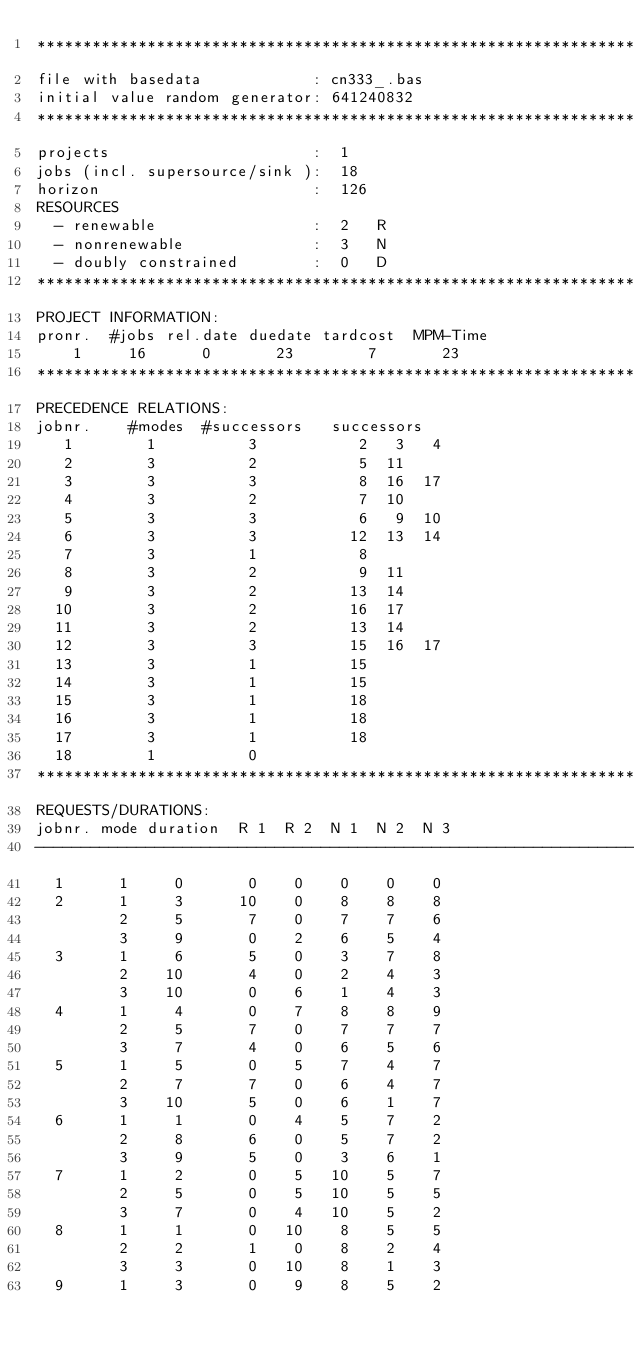<code> <loc_0><loc_0><loc_500><loc_500><_ObjectiveC_>************************************************************************
file with basedata            : cn333_.bas
initial value random generator: 641240832
************************************************************************
projects                      :  1
jobs (incl. supersource/sink ):  18
horizon                       :  126
RESOURCES
  - renewable                 :  2   R
  - nonrenewable              :  3   N
  - doubly constrained        :  0   D
************************************************************************
PROJECT INFORMATION:
pronr.  #jobs rel.date duedate tardcost  MPM-Time
    1     16      0       23        7       23
************************************************************************
PRECEDENCE RELATIONS:
jobnr.    #modes  #successors   successors
   1        1          3           2   3   4
   2        3          2           5  11
   3        3          3           8  16  17
   4        3          2           7  10
   5        3          3           6   9  10
   6        3          3          12  13  14
   7        3          1           8
   8        3          2           9  11
   9        3          2          13  14
  10        3          2          16  17
  11        3          2          13  14
  12        3          3          15  16  17
  13        3          1          15
  14        3          1          15
  15        3          1          18
  16        3          1          18
  17        3          1          18
  18        1          0        
************************************************************************
REQUESTS/DURATIONS:
jobnr. mode duration  R 1  R 2  N 1  N 2  N 3
------------------------------------------------------------------------
  1      1     0       0    0    0    0    0
  2      1     3      10    0    8    8    8
         2     5       7    0    7    7    6
         3     9       0    2    6    5    4
  3      1     6       5    0    3    7    8
         2    10       4    0    2    4    3
         3    10       0    6    1    4    3
  4      1     4       0    7    8    8    9
         2     5       7    0    7    7    7
         3     7       4    0    6    5    6
  5      1     5       0    5    7    4    7
         2     7       7    0    6    4    7
         3    10       5    0    6    1    7
  6      1     1       0    4    5    7    2
         2     8       6    0    5    7    2
         3     9       5    0    3    6    1
  7      1     2       0    5   10    5    7
         2     5       0    5   10    5    5
         3     7       0    4   10    5    2
  8      1     1       0   10    8    5    5
         2     2       1    0    8    2    4
         3     3       0   10    8    1    3
  9      1     3       0    9    8    5    2</code> 